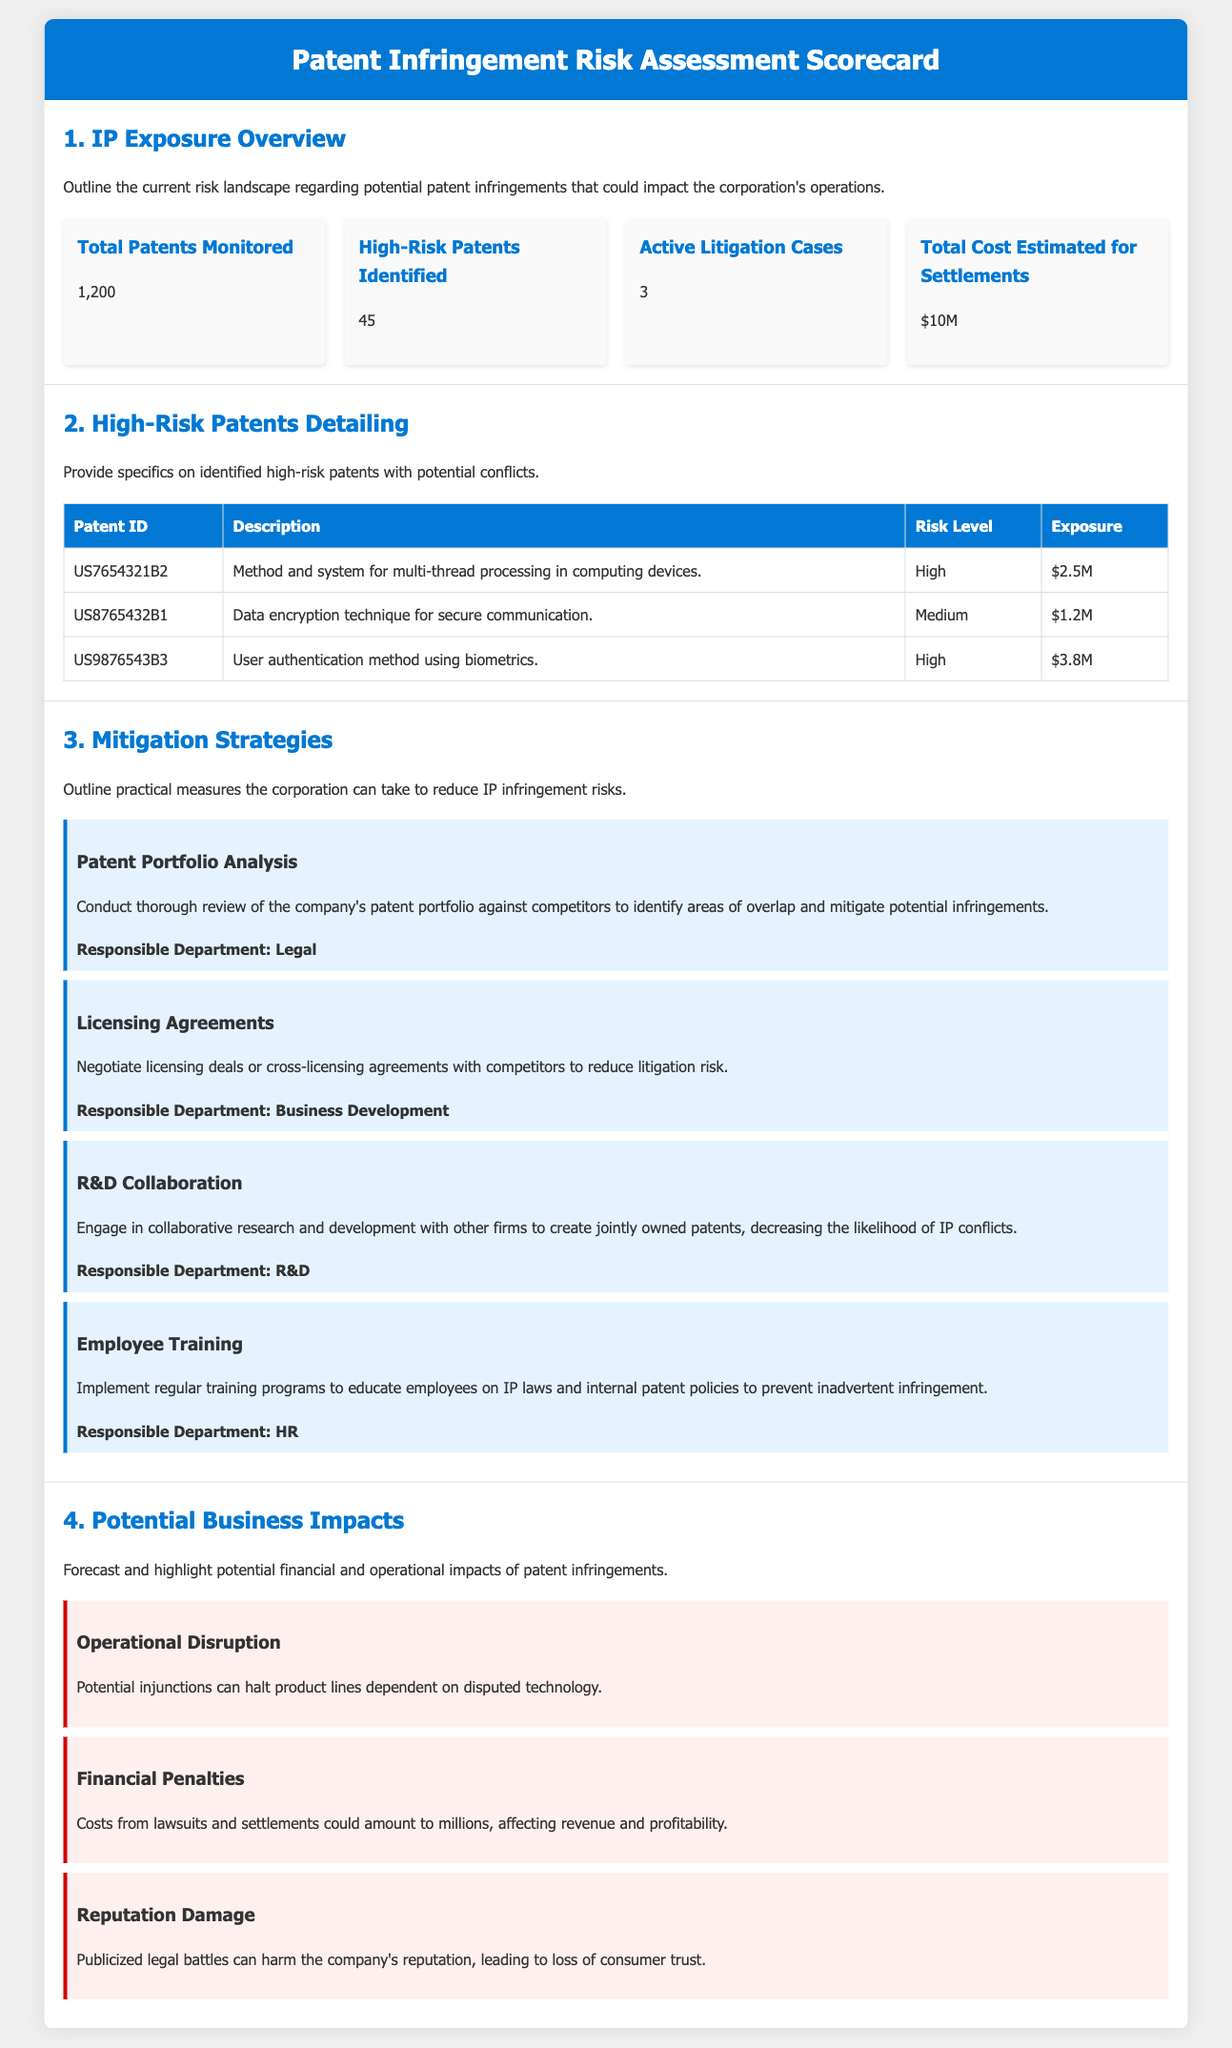what is the total number of patents monitored? The total number of patents monitored is explicitly stated in the document under the IP Exposure Overview section.
Answer: 1,200 how many high-risk patents are identified? The document clearly indicates the number of high-risk patents in the IP Exposure Overview section.
Answer: 45 what is the estimated total cost for settlements? The estimated total cost for settlements is presented in the IP Exposure Overview section.
Answer: $10M which department is responsible for patent portfolio analysis? The responsible department for the proposed strategy of patent portfolio analysis is outlined in the Mitigation Strategies section.
Answer: Legal what is the risk level of the patent US9876543B3? The risk level of the specified patent can be found in the High-Risk Patents Detailing section.
Answer: High what potential impact involves operational disruption? The potential impact related to operational disruption is mentioned in the Potential Business Impacts section.
Answer: Potential injunctions can halt product lines dependent on disputed technology how many active litigation cases are mentioned? The number of active litigation cases is provided in the IP Exposure Overview section.
Answer: 3 what is the exposure amount for the patent US7654321B2? The exposure amount for this patent is listed in the High-Risk Patents Detailing table.
Answer: $2.5M what strategy involves educational programs for employees? The strategy that focuses on educational programs is specified in the Mitigation Strategies section.
Answer: Employee Training 